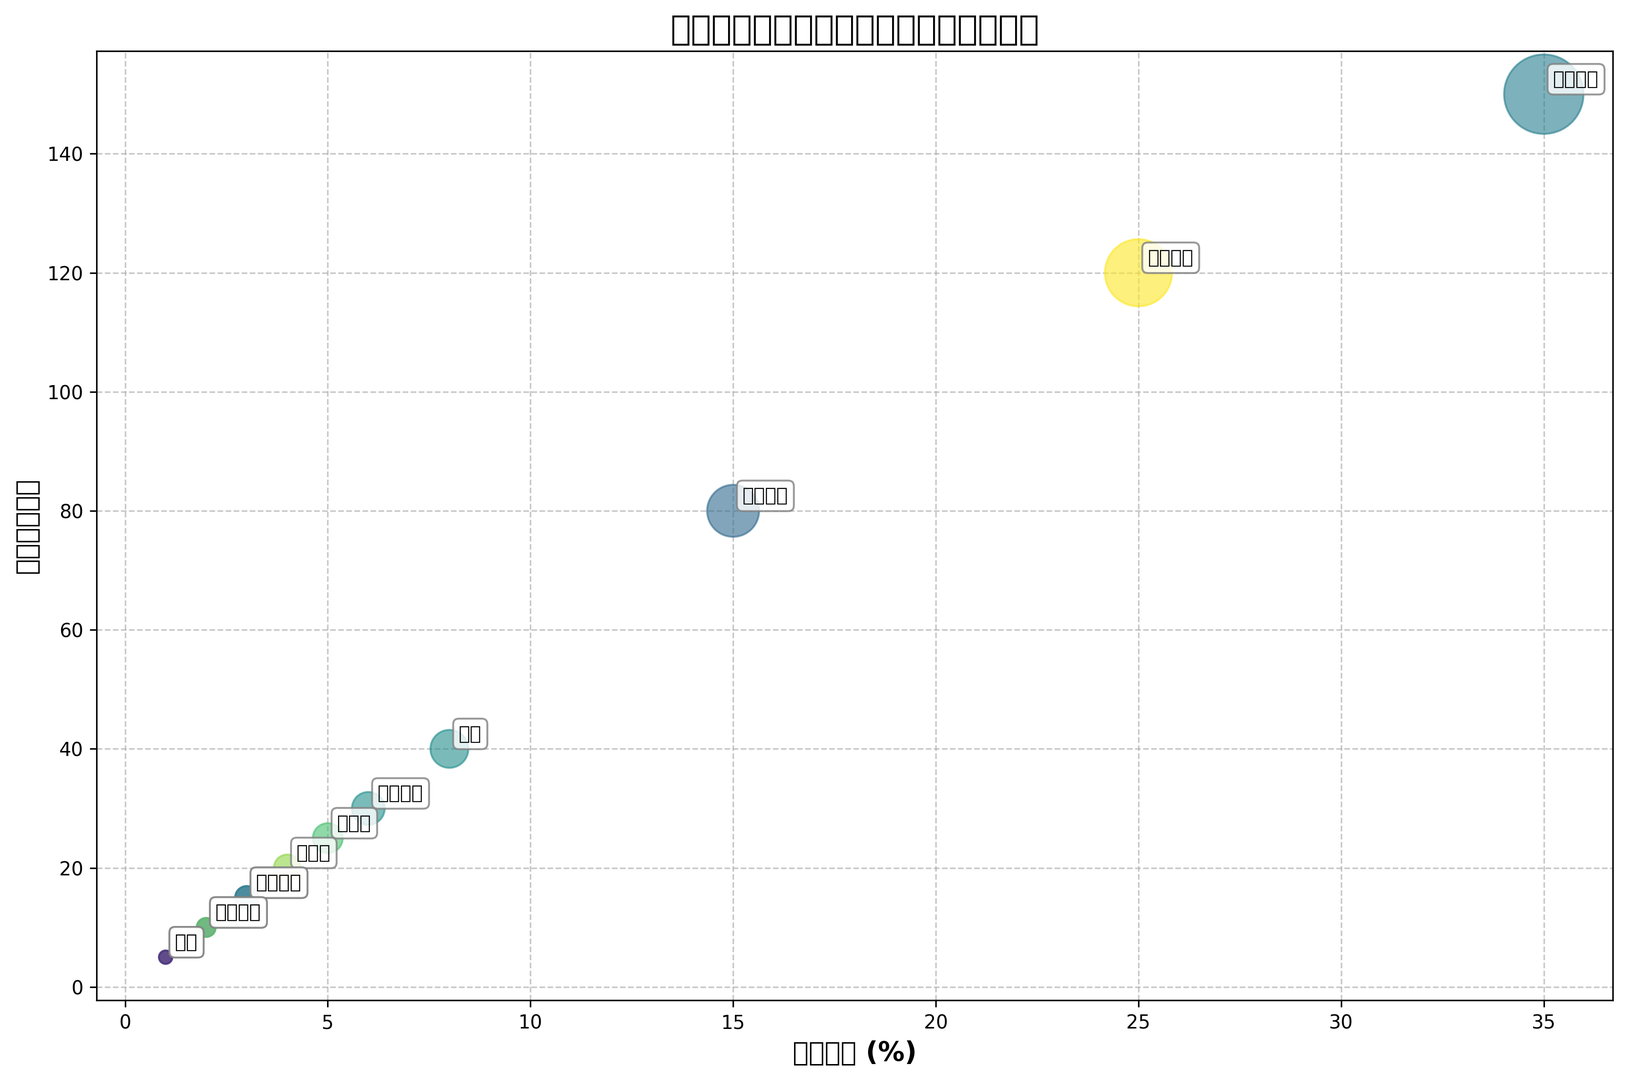少年漫画的市场份额是多少，作品数有多少？ 根据图表，少年漫画的市场份额是35%，代表作品有150部
Answer: 35%，150部 哪个流派的代表作品数量最多？ 图表上显示代表作品数量最高的是少年漫画，有150部
Answer: 少年漫画 魔法少女的市场份额高于还是低于异世界？ 根据图表的垂直位置和气泡大小，魔法少女的市场份额（6%）高于异世界（5%）
Answer: 高于 市场份额在5%以下的流派有哪些？ 从图表中可以看出市场份额在5%以下的流派包括异世界、日常系、悬疑推理、体育运动、料理美食、音乐偶像、历史和恐怖
Answer: 异世界、日常系、悬疑推理、体育运动、料理美食、音乐偶像、历史、恐怖 如何比较少年漫画和少女漫画的市场份额和代表作品数量？ 根据图表，少年漫画的市场份额是35%，代表作品数为150部；少女漫画的市场份额是25%，代表作品数为120部。少年漫画在市场份额和代表作品数量上都高于少女漫画
Answer: 少年漫画在市场份额和代表作品数量上都高于少女漫画 哪个流派的泡泡最小，它代表什么？ 图表中泡泡最小的流派是历史和恐怖，它们的市场份额均为1%，代表作品数量为5部
Answer: 历史和恐怖 市场份额最大的三个流派的总市场份额是多少？ 根据图表，市场份额最大的三个流派是少年漫画、少女漫画和青年漫画，市场份额分别是35%、25%和15%。总市场份额为35 + 25 + 15 = 75%
Answer: 75% 日常系和机战的代表作品数量相差多少？ 日常系的代表作品数量是20部，机战是40部。因此，机战比日常系多40 - 20 = 20部作品
Answer: 20部 颜色最亮的流派是什么？ 虽然具体颜色在编程中随机生成，根据颜色对比，图表中颜色最亮的流派视觉上似乎对应魔法少女
Answer: 魔法少女 